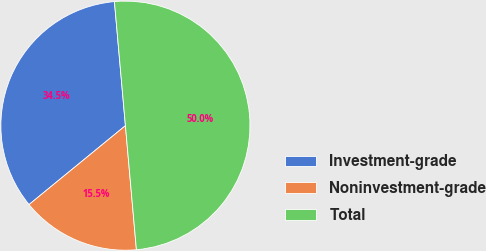<chart> <loc_0><loc_0><loc_500><loc_500><pie_chart><fcel>Investment-grade<fcel>Noninvestment-grade<fcel>Total<nl><fcel>34.51%<fcel>15.49%<fcel>50.0%<nl></chart> 